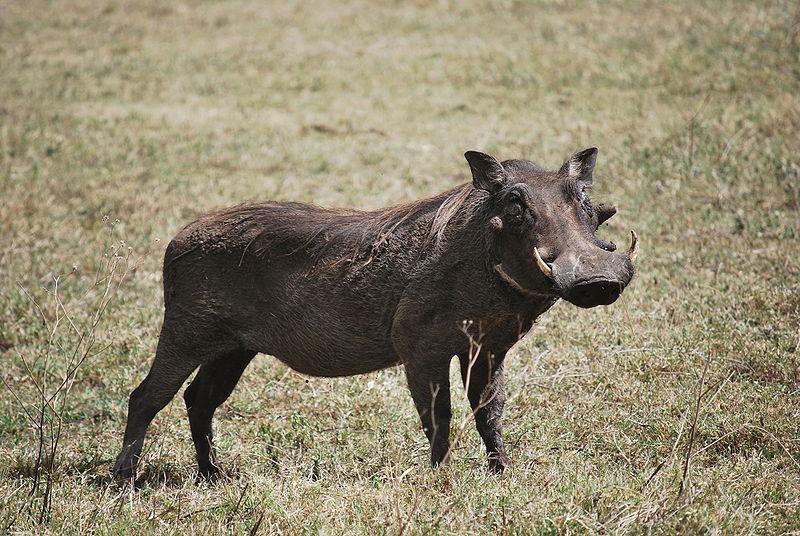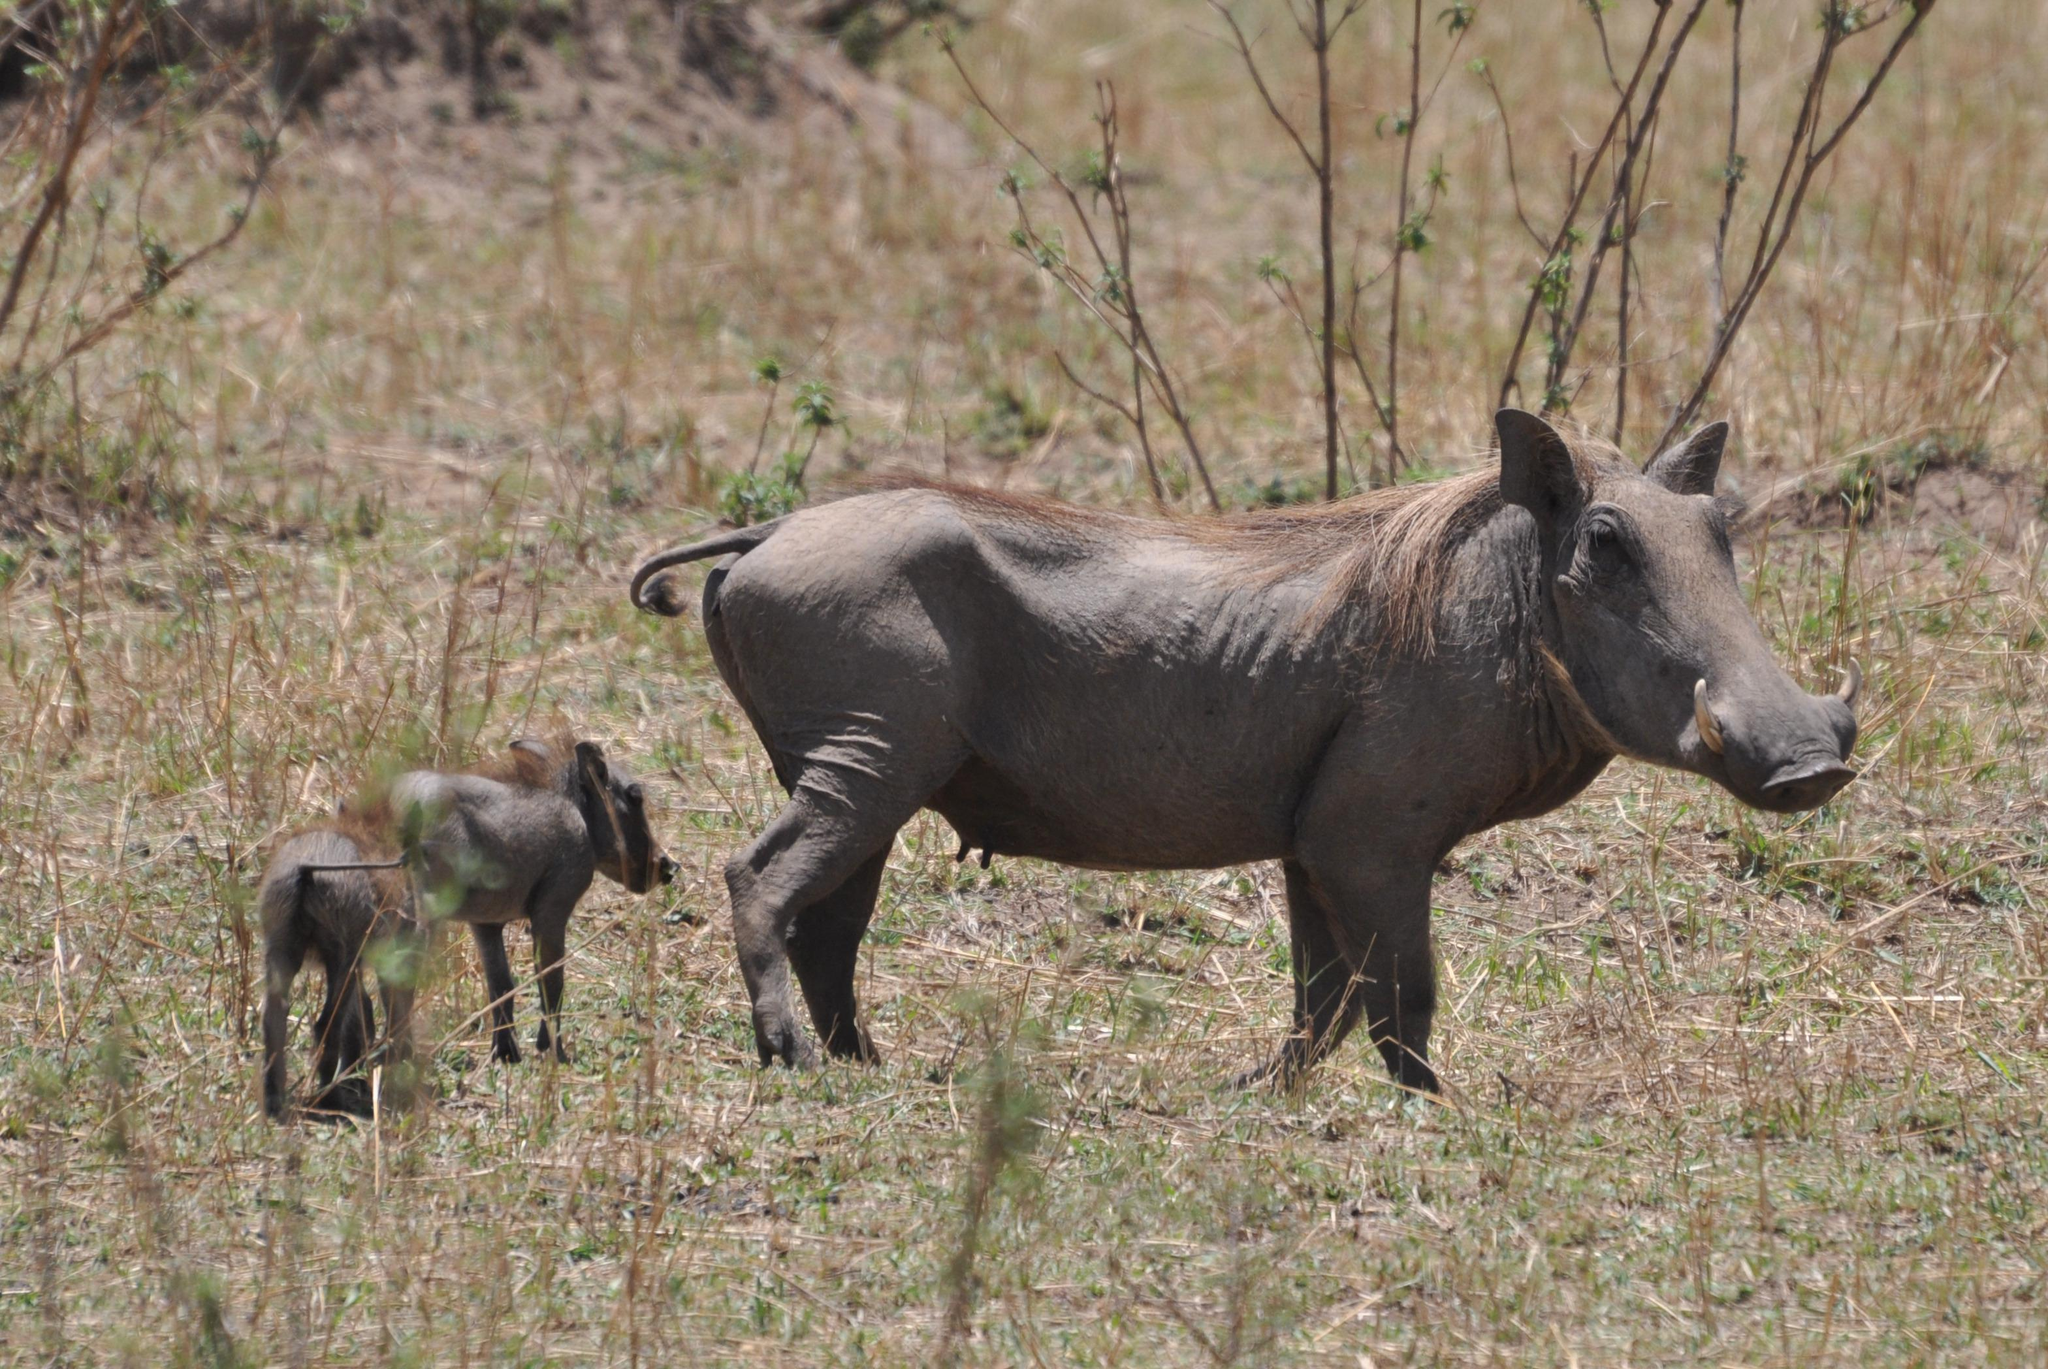The first image is the image on the left, the second image is the image on the right. Assess this claim about the two images: "Left image shows one warthog with body in profile turned to the right.". Correct or not? Answer yes or no. Yes. 